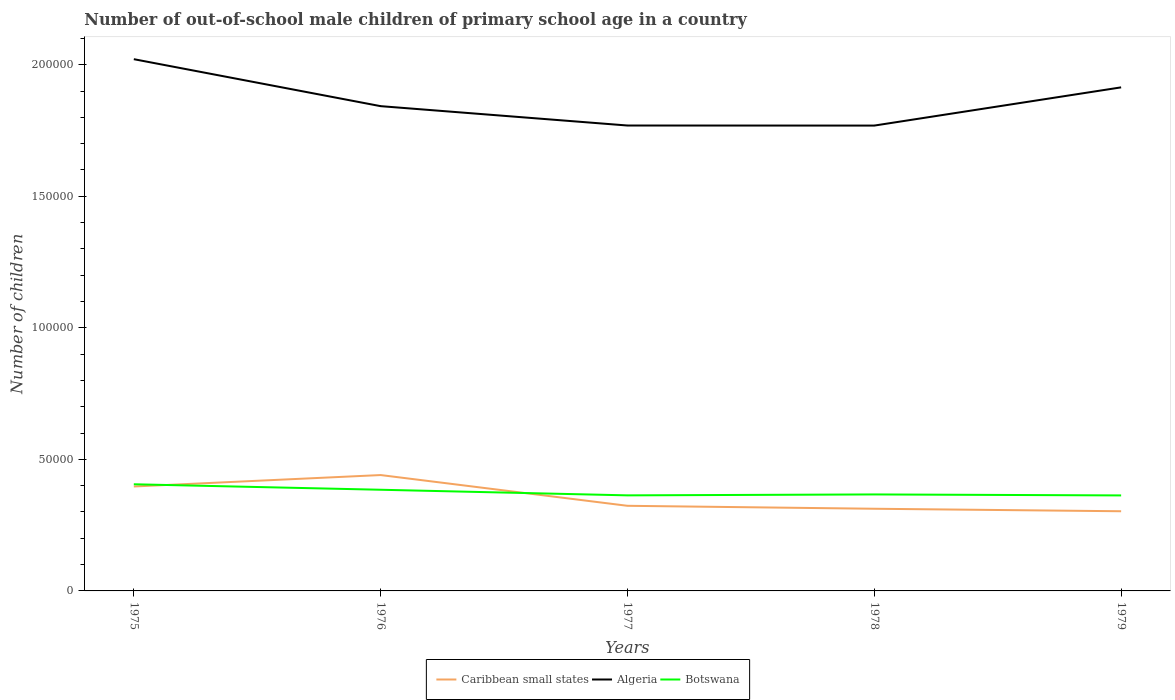Does the line corresponding to Botswana intersect with the line corresponding to Algeria?
Give a very brief answer. No. Is the number of lines equal to the number of legend labels?
Offer a very short reply. Yes. Across all years, what is the maximum number of out-of-school male children in Caribbean small states?
Give a very brief answer. 3.03e+04. In which year was the number of out-of-school male children in Algeria maximum?
Give a very brief answer. 1978. What is the total number of out-of-school male children in Botswana in the graph?
Your response must be concise. 2131. What is the difference between the highest and the second highest number of out-of-school male children in Caribbean small states?
Make the answer very short. 1.38e+04. Is the number of out-of-school male children in Algeria strictly greater than the number of out-of-school male children in Botswana over the years?
Your answer should be compact. No. How many lines are there?
Give a very brief answer. 3. Does the graph contain any zero values?
Keep it short and to the point. No. Does the graph contain grids?
Provide a succinct answer. No. How are the legend labels stacked?
Provide a short and direct response. Horizontal. What is the title of the graph?
Your response must be concise. Number of out-of-school male children of primary school age in a country. What is the label or title of the X-axis?
Make the answer very short. Years. What is the label or title of the Y-axis?
Your answer should be very brief. Number of children. What is the Number of children in Caribbean small states in 1975?
Ensure brevity in your answer.  3.97e+04. What is the Number of children in Algeria in 1975?
Your answer should be very brief. 2.02e+05. What is the Number of children of Botswana in 1975?
Keep it short and to the point. 4.05e+04. What is the Number of children in Caribbean small states in 1976?
Make the answer very short. 4.40e+04. What is the Number of children in Algeria in 1976?
Your answer should be very brief. 1.84e+05. What is the Number of children of Botswana in 1976?
Offer a terse response. 3.84e+04. What is the Number of children in Caribbean small states in 1977?
Ensure brevity in your answer.  3.24e+04. What is the Number of children of Algeria in 1977?
Offer a very short reply. 1.77e+05. What is the Number of children in Botswana in 1977?
Your answer should be compact. 3.63e+04. What is the Number of children of Caribbean small states in 1978?
Your answer should be very brief. 3.12e+04. What is the Number of children in Algeria in 1978?
Your response must be concise. 1.77e+05. What is the Number of children of Botswana in 1978?
Provide a succinct answer. 3.67e+04. What is the Number of children in Caribbean small states in 1979?
Ensure brevity in your answer.  3.03e+04. What is the Number of children in Algeria in 1979?
Make the answer very short. 1.91e+05. What is the Number of children in Botswana in 1979?
Ensure brevity in your answer.  3.63e+04. Across all years, what is the maximum Number of children of Caribbean small states?
Provide a succinct answer. 4.40e+04. Across all years, what is the maximum Number of children in Algeria?
Offer a very short reply. 2.02e+05. Across all years, what is the maximum Number of children of Botswana?
Provide a short and direct response. 4.05e+04. Across all years, what is the minimum Number of children of Caribbean small states?
Your answer should be very brief. 3.03e+04. Across all years, what is the minimum Number of children in Algeria?
Ensure brevity in your answer.  1.77e+05. Across all years, what is the minimum Number of children of Botswana?
Provide a succinct answer. 3.63e+04. What is the total Number of children in Caribbean small states in the graph?
Ensure brevity in your answer.  1.78e+05. What is the total Number of children of Algeria in the graph?
Your answer should be very brief. 9.31e+05. What is the total Number of children in Botswana in the graph?
Ensure brevity in your answer.  1.88e+05. What is the difference between the Number of children of Caribbean small states in 1975 and that in 1976?
Your answer should be compact. -4347. What is the difference between the Number of children of Algeria in 1975 and that in 1976?
Keep it short and to the point. 1.79e+04. What is the difference between the Number of children of Botswana in 1975 and that in 1976?
Provide a succinct answer. 2085. What is the difference between the Number of children in Caribbean small states in 1975 and that in 1977?
Ensure brevity in your answer.  7338. What is the difference between the Number of children of Algeria in 1975 and that in 1977?
Your answer should be compact. 2.52e+04. What is the difference between the Number of children in Botswana in 1975 and that in 1977?
Make the answer very short. 4216. What is the difference between the Number of children of Caribbean small states in 1975 and that in 1978?
Make the answer very short. 8461. What is the difference between the Number of children in Algeria in 1975 and that in 1978?
Ensure brevity in your answer.  2.52e+04. What is the difference between the Number of children in Botswana in 1975 and that in 1978?
Offer a terse response. 3862. What is the difference between the Number of children of Caribbean small states in 1975 and that in 1979?
Offer a terse response. 9411. What is the difference between the Number of children of Algeria in 1975 and that in 1979?
Offer a terse response. 1.07e+04. What is the difference between the Number of children of Botswana in 1975 and that in 1979?
Your answer should be very brief. 4236. What is the difference between the Number of children in Caribbean small states in 1976 and that in 1977?
Offer a very short reply. 1.17e+04. What is the difference between the Number of children of Algeria in 1976 and that in 1977?
Provide a short and direct response. 7356. What is the difference between the Number of children of Botswana in 1976 and that in 1977?
Give a very brief answer. 2131. What is the difference between the Number of children of Caribbean small states in 1976 and that in 1978?
Give a very brief answer. 1.28e+04. What is the difference between the Number of children in Algeria in 1976 and that in 1978?
Your answer should be compact. 7382. What is the difference between the Number of children of Botswana in 1976 and that in 1978?
Your answer should be very brief. 1777. What is the difference between the Number of children in Caribbean small states in 1976 and that in 1979?
Offer a very short reply. 1.38e+04. What is the difference between the Number of children in Algeria in 1976 and that in 1979?
Your answer should be very brief. -7145. What is the difference between the Number of children in Botswana in 1976 and that in 1979?
Ensure brevity in your answer.  2151. What is the difference between the Number of children of Caribbean small states in 1977 and that in 1978?
Give a very brief answer. 1123. What is the difference between the Number of children of Algeria in 1977 and that in 1978?
Your answer should be very brief. 26. What is the difference between the Number of children in Botswana in 1977 and that in 1978?
Your response must be concise. -354. What is the difference between the Number of children of Caribbean small states in 1977 and that in 1979?
Your answer should be very brief. 2073. What is the difference between the Number of children in Algeria in 1977 and that in 1979?
Ensure brevity in your answer.  -1.45e+04. What is the difference between the Number of children in Caribbean small states in 1978 and that in 1979?
Your response must be concise. 950. What is the difference between the Number of children of Algeria in 1978 and that in 1979?
Keep it short and to the point. -1.45e+04. What is the difference between the Number of children of Botswana in 1978 and that in 1979?
Provide a succinct answer. 374. What is the difference between the Number of children in Caribbean small states in 1975 and the Number of children in Algeria in 1976?
Your answer should be compact. -1.45e+05. What is the difference between the Number of children of Caribbean small states in 1975 and the Number of children of Botswana in 1976?
Make the answer very short. 1241. What is the difference between the Number of children in Algeria in 1975 and the Number of children in Botswana in 1976?
Your answer should be very brief. 1.64e+05. What is the difference between the Number of children of Caribbean small states in 1975 and the Number of children of Algeria in 1977?
Your response must be concise. -1.37e+05. What is the difference between the Number of children in Caribbean small states in 1975 and the Number of children in Botswana in 1977?
Offer a terse response. 3372. What is the difference between the Number of children of Algeria in 1975 and the Number of children of Botswana in 1977?
Ensure brevity in your answer.  1.66e+05. What is the difference between the Number of children of Caribbean small states in 1975 and the Number of children of Algeria in 1978?
Keep it short and to the point. -1.37e+05. What is the difference between the Number of children in Caribbean small states in 1975 and the Number of children in Botswana in 1978?
Provide a succinct answer. 3018. What is the difference between the Number of children of Algeria in 1975 and the Number of children of Botswana in 1978?
Give a very brief answer. 1.65e+05. What is the difference between the Number of children of Caribbean small states in 1975 and the Number of children of Algeria in 1979?
Your answer should be compact. -1.52e+05. What is the difference between the Number of children in Caribbean small states in 1975 and the Number of children in Botswana in 1979?
Offer a very short reply. 3392. What is the difference between the Number of children of Algeria in 1975 and the Number of children of Botswana in 1979?
Keep it short and to the point. 1.66e+05. What is the difference between the Number of children of Caribbean small states in 1976 and the Number of children of Algeria in 1977?
Provide a succinct answer. -1.33e+05. What is the difference between the Number of children in Caribbean small states in 1976 and the Number of children in Botswana in 1977?
Your answer should be compact. 7719. What is the difference between the Number of children of Algeria in 1976 and the Number of children of Botswana in 1977?
Keep it short and to the point. 1.48e+05. What is the difference between the Number of children of Caribbean small states in 1976 and the Number of children of Algeria in 1978?
Provide a succinct answer. -1.33e+05. What is the difference between the Number of children of Caribbean small states in 1976 and the Number of children of Botswana in 1978?
Your answer should be very brief. 7365. What is the difference between the Number of children in Algeria in 1976 and the Number of children in Botswana in 1978?
Your response must be concise. 1.48e+05. What is the difference between the Number of children in Caribbean small states in 1976 and the Number of children in Algeria in 1979?
Offer a very short reply. -1.47e+05. What is the difference between the Number of children of Caribbean small states in 1976 and the Number of children of Botswana in 1979?
Offer a very short reply. 7739. What is the difference between the Number of children in Algeria in 1976 and the Number of children in Botswana in 1979?
Offer a very short reply. 1.48e+05. What is the difference between the Number of children in Caribbean small states in 1977 and the Number of children in Algeria in 1978?
Give a very brief answer. -1.45e+05. What is the difference between the Number of children of Caribbean small states in 1977 and the Number of children of Botswana in 1978?
Provide a succinct answer. -4320. What is the difference between the Number of children in Algeria in 1977 and the Number of children in Botswana in 1978?
Your answer should be compact. 1.40e+05. What is the difference between the Number of children of Caribbean small states in 1977 and the Number of children of Algeria in 1979?
Ensure brevity in your answer.  -1.59e+05. What is the difference between the Number of children in Caribbean small states in 1977 and the Number of children in Botswana in 1979?
Ensure brevity in your answer.  -3946. What is the difference between the Number of children in Algeria in 1977 and the Number of children in Botswana in 1979?
Offer a terse response. 1.41e+05. What is the difference between the Number of children of Caribbean small states in 1978 and the Number of children of Algeria in 1979?
Make the answer very short. -1.60e+05. What is the difference between the Number of children in Caribbean small states in 1978 and the Number of children in Botswana in 1979?
Make the answer very short. -5069. What is the difference between the Number of children in Algeria in 1978 and the Number of children in Botswana in 1979?
Offer a terse response. 1.41e+05. What is the average Number of children in Caribbean small states per year?
Your response must be concise. 3.55e+04. What is the average Number of children in Algeria per year?
Give a very brief answer. 1.86e+05. What is the average Number of children of Botswana per year?
Your answer should be very brief. 3.77e+04. In the year 1975, what is the difference between the Number of children of Caribbean small states and Number of children of Algeria?
Make the answer very short. -1.62e+05. In the year 1975, what is the difference between the Number of children in Caribbean small states and Number of children in Botswana?
Offer a terse response. -844. In the year 1975, what is the difference between the Number of children in Algeria and Number of children in Botswana?
Your answer should be very brief. 1.62e+05. In the year 1976, what is the difference between the Number of children of Caribbean small states and Number of children of Algeria?
Provide a short and direct response. -1.40e+05. In the year 1976, what is the difference between the Number of children in Caribbean small states and Number of children in Botswana?
Offer a very short reply. 5588. In the year 1976, what is the difference between the Number of children of Algeria and Number of children of Botswana?
Your answer should be very brief. 1.46e+05. In the year 1977, what is the difference between the Number of children in Caribbean small states and Number of children in Algeria?
Your response must be concise. -1.45e+05. In the year 1977, what is the difference between the Number of children in Caribbean small states and Number of children in Botswana?
Offer a terse response. -3966. In the year 1977, what is the difference between the Number of children in Algeria and Number of children in Botswana?
Offer a terse response. 1.41e+05. In the year 1978, what is the difference between the Number of children in Caribbean small states and Number of children in Algeria?
Provide a short and direct response. -1.46e+05. In the year 1978, what is the difference between the Number of children in Caribbean small states and Number of children in Botswana?
Offer a very short reply. -5443. In the year 1978, what is the difference between the Number of children of Algeria and Number of children of Botswana?
Provide a short and direct response. 1.40e+05. In the year 1979, what is the difference between the Number of children of Caribbean small states and Number of children of Algeria?
Give a very brief answer. -1.61e+05. In the year 1979, what is the difference between the Number of children of Caribbean small states and Number of children of Botswana?
Ensure brevity in your answer.  -6019. In the year 1979, what is the difference between the Number of children in Algeria and Number of children in Botswana?
Your answer should be very brief. 1.55e+05. What is the ratio of the Number of children in Caribbean small states in 1975 to that in 1976?
Your answer should be very brief. 0.9. What is the ratio of the Number of children in Algeria in 1975 to that in 1976?
Offer a terse response. 1.1. What is the ratio of the Number of children in Botswana in 1975 to that in 1976?
Ensure brevity in your answer.  1.05. What is the ratio of the Number of children in Caribbean small states in 1975 to that in 1977?
Keep it short and to the point. 1.23. What is the ratio of the Number of children in Algeria in 1975 to that in 1977?
Keep it short and to the point. 1.14. What is the ratio of the Number of children of Botswana in 1975 to that in 1977?
Make the answer very short. 1.12. What is the ratio of the Number of children in Caribbean small states in 1975 to that in 1978?
Make the answer very short. 1.27. What is the ratio of the Number of children of Algeria in 1975 to that in 1978?
Give a very brief answer. 1.14. What is the ratio of the Number of children of Botswana in 1975 to that in 1978?
Your response must be concise. 1.11. What is the ratio of the Number of children of Caribbean small states in 1975 to that in 1979?
Make the answer very short. 1.31. What is the ratio of the Number of children of Algeria in 1975 to that in 1979?
Provide a succinct answer. 1.06. What is the ratio of the Number of children of Botswana in 1975 to that in 1979?
Offer a very short reply. 1.12. What is the ratio of the Number of children of Caribbean small states in 1976 to that in 1977?
Provide a short and direct response. 1.36. What is the ratio of the Number of children of Algeria in 1976 to that in 1977?
Your answer should be very brief. 1.04. What is the ratio of the Number of children of Botswana in 1976 to that in 1977?
Provide a succinct answer. 1.06. What is the ratio of the Number of children of Caribbean small states in 1976 to that in 1978?
Give a very brief answer. 1.41. What is the ratio of the Number of children in Algeria in 1976 to that in 1978?
Your answer should be compact. 1.04. What is the ratio of the Number of children in Botswana in 1976 to that in 1978?
Give a very brief answer. 1.05. What is the ratio of the Number of children in Caribbean small states in 1976 to that in 1979?
Provide a succinct answer. 1.45. What is the ratio of the Number of children of Algeria in 1976 to that in 1979?
Offer a very short reply. 0.96. What is the ratio of the Number of children of Botswana in 1976 to that in 1979?
Your response must be concise. 1.06. What is the ratio of the Number of children in Caribbean small states in 1977 to that in 1978?
Your answer should be compact. 1.04. What is the ratio of the Number of children of Algeria in 1977 to that in 1978?
Your answer should be compact. 1. What is the ratio of the Number of children in Botswana in 1977 to that in 1978?
Your answer should be compact. 0.99. What is the ratio of the Number of children in Caribbean small states in 1977 to that in 1979?
Provide a succinct answer. 1.07. What is the ratio of the Number of children in Algeria in 1977 to that in 1979?
Your answer should be compact. 0.92. What is the ratio of the Number of children in Botswana in 1977 to that in 1979?
Your response must be concise. 1. What is the ratio of the Number of children in Caribbean small states in 1978 to that in 1979?
Your response must be concise. 1.03. What is the ratio of the Number of children in Algeria in 1978 to that in 1979?
Provide a short and direct response. 0.92. What is the ratio of the Number of children of Botswana in 1978 to that in 1979?
Offer a terse response. 1.01. What is the difference between the highest and the second highest Number of children in Caribbean small states?
Ensure brevity in your answer.  4347. What is the difference between the highest and the second highest Number of children in Algeria?
Your answer should be very brief. 1.07e+04. What is the difference between the highest and the second highest Number of children of Botswana?
Make the answer very short. 2085. What is the difference between the highest and the lowest Number of children in Caribbean small states?
Provide a succinct answer. 1.38e+04. What is the difference between the highest and the lowest Number of children in Algeria?
Ensure brevity in your answer.  2.52e+04. What is the difference between the highest and the lowest Number of children in Botswana?
Your answer should be compact. 4236. 